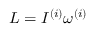Convert formula to latex. <formula><loc_0><loc_0><loc_500><loc_500>L = I ^ { ( i ) } \omega ^ { ( i ) }</formula> 